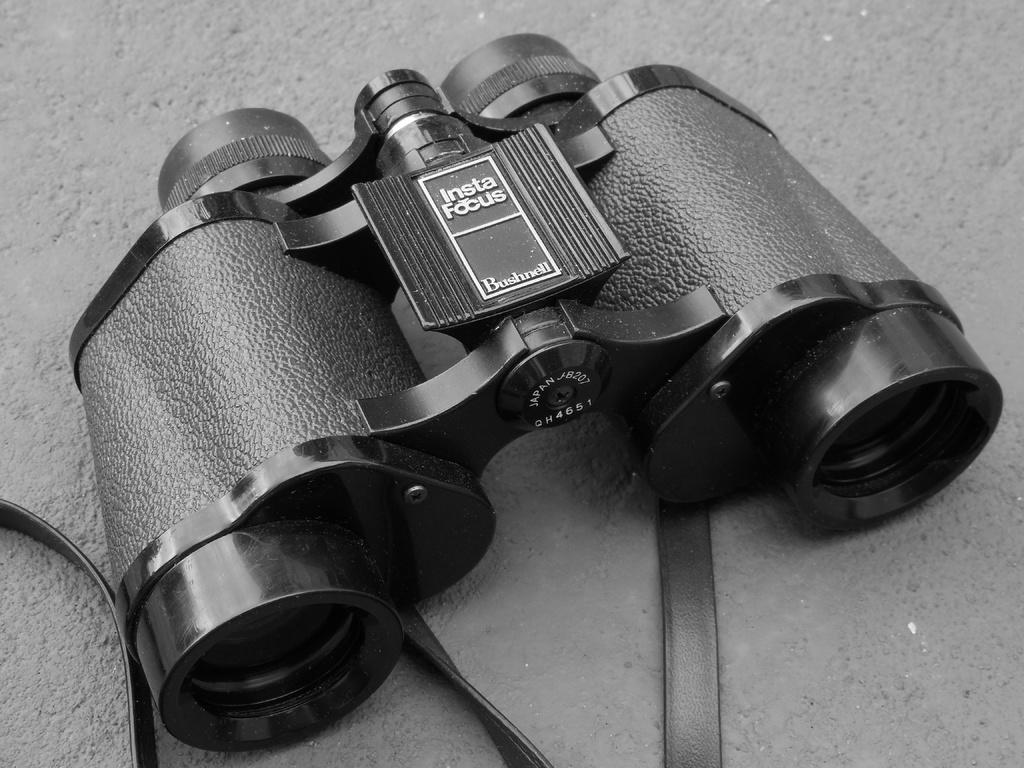What is the color scheme of the image? The image is black and white. What object is present in the image? There is a binocular in the image. On what surface is the binocular placed? The binocular is on a concrete surface. Where is the jail located in the image? There is no jail present in the image. What type of drink is being shaken in the image? There is no drink or shaking motion present in the image. 